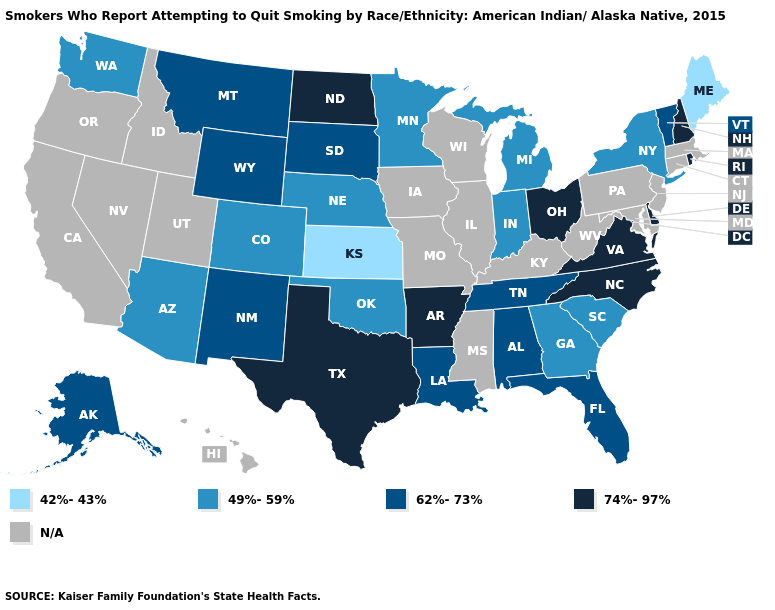What is the lowest value in the USA?
Give a very brief answer. 42%-43%. What is the highest value in the MidWest ?
Be succinct. 74%-97%. What is the lowest value in the USA?
Give a very brief answer. 42%-43%. What is the value of Kansas?
Be succinct. 42%-43%. Name the states that have a value in the range 62%-73%?
Keep it brief. Alabama, Alaska, Florida, Louisiana, Montana, New Mexico, South Dakota, Tennessee, Vermont, Wyoming. What is the value of Missouri?
Concise answer only. N/A. Is the legend a continuous bar?
Concise answer only. No. Which states have the lowest value in the USA?
Quick response, please. Kansas, Maine. What is the highest value in states that border Maine?
Answer briefly. 74%-97%. Name the states that have a value in the range 42%-43%?
Keep it brief. Kansas, Maine. What is the value of South Dakota?
Quick response, please. 62%-73%. What is the highest value in the USA?
Be succinct. 74%-97%. What is the value of Virginia?
Quick response, please. 74%-97%. Which states have the lowest value in the MidWest?
Short answer required. Kansas. 